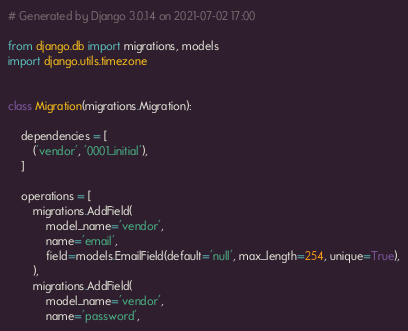<code> <loc_0><loc_0><loc_500><loc_500><_Python_># Generated by Django 3.0.14 on 2021-07-02 17:00

from django.db import migrations, models
import django.utils.timezone


class Migration(migrations.Migration):

    dependencies = [
        ('vendor', '0001_initial'),
    ]

    operations = [
        migrations.AddField(
            model_name='vendor',
            name='email',
            field=models.EmailField(default='null', max_length=254, unique=True),
        ),
        migrations.AddField(
            model_name='vendor',
            name='password',</code> 